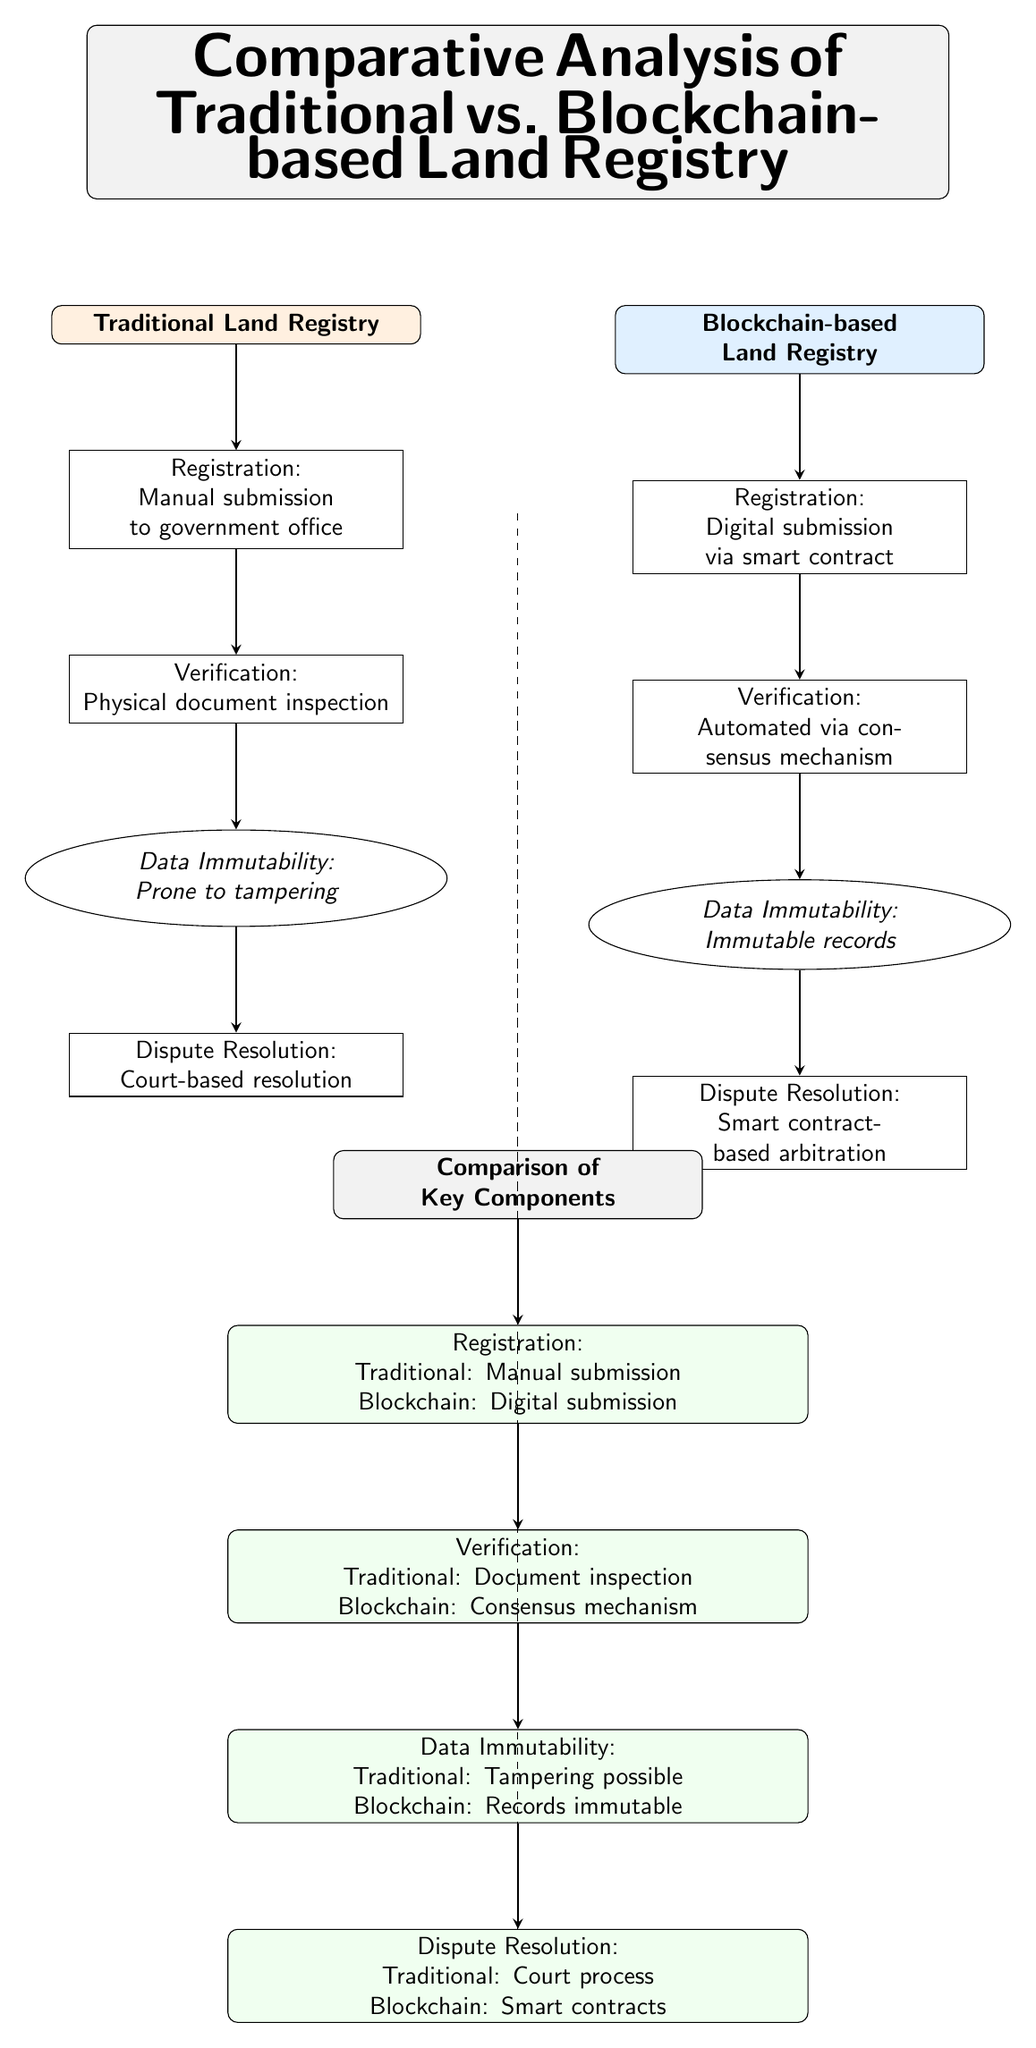What are the two types of land registries compared in the diagram? The diagram clearly labels two categories at the top: "Traditional Land Registry" on the left and "Blockchain-based Land Registry" on the right.
Answer: Traditional Land Registry, Blockchain-based Land Registry How many processes are involved in the traditional land registry? By counting the nodes listed under the "Traditional Land Registry," we see there are four processes: Registration, Verification, Data Immutability, and Dispute Resolution.
Answer: Four What mechanism is used for verification in the blockchain land registry? The diagram indicates that the verification process for the blockchain land registry is "Automated via consensus mechanism," as denoted beneath the registration bubble.
Answer: Automated via consensus mechanism What is the key feature of data immutability in the traditional land registry? The diagram specifies that the traditional land registry's data immutability is "Prone to tampering," which reveals its vulnerability compared to blockchain.
Answer: Prone to tampering Which process in blockchain-based land registry has a corresponding comparison point in traditional land registry? The diagram illustrates that all four processes in traditional land registry have corresponding points in the blockchain system. Focusing specifically on dispute resolution, it is labeled as "Court process" for traditional, compared to "Smart contracts" for blockchain.
Answer: Dispute Resolution What is the primary advantage of blockchain over traditional land registry in relation to data immutability? The diagram notes that in the blockchain land registry, data immutability is described as "Immutable records," indicating a significant advantage over traditional, where tampering is possible.
Answer: Immutable records Which registration method is used in the traditional land registry? According to the diagram, the method for registration in the traditional land registry is "Manual submission to government office," indicating a more labor-intensive process.
Answer: Manual submission to government office What is the entire flow of processes in the blockchain-based land registry starting from registration? The flow starts with "Digital submission via smart contract," which leads to "Automated via consensus mechanism," followed by "Immutable records," and concludes with "Smart contract-based arbitration." This sequence shows a streamlined process enabled by technology.
Answer: Digital submission, Automated, Immutable records, Smart contract-based arbitration 